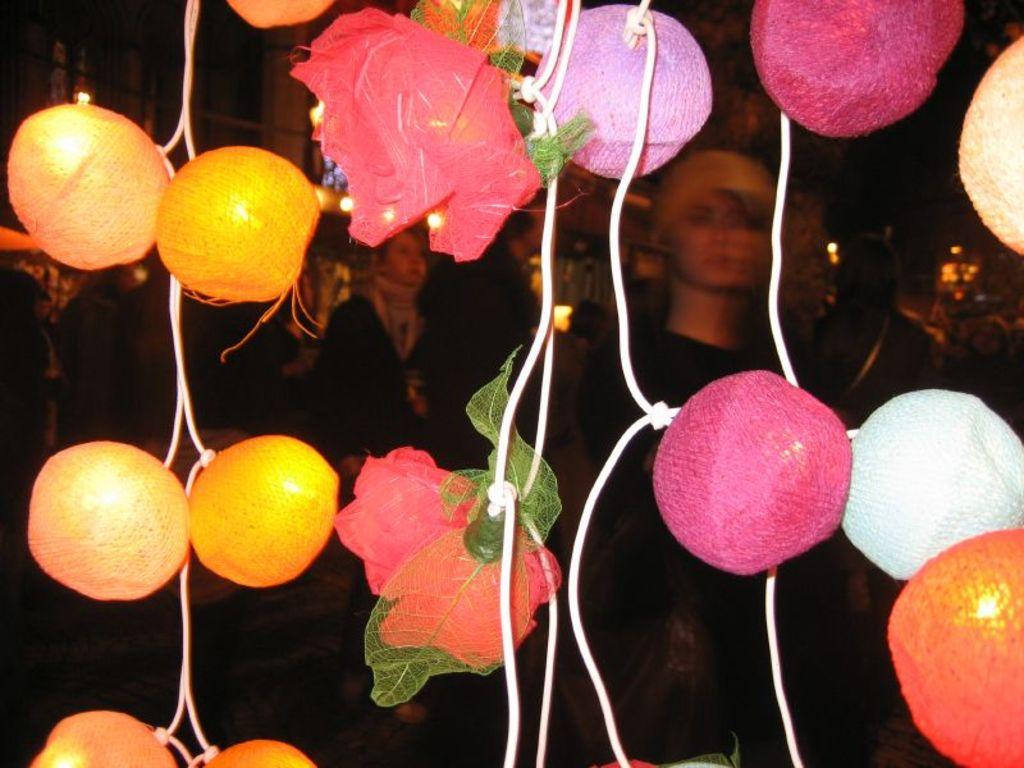What type of objects can be seen in the image? There are decorative balls and flowers in the image. Are there any living beings present in the image? Yes, there are people wearing clothes in the image. What can be used to provide illumination in the image? There is a light in the image. What type of trade is being conducted in the image? There is no indication of any trade being conducted in the image. Can you see any smoke coming from the decorative balls in the image? No, there is no smoke present in the image. 